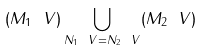Convert formula to latex. <formula><loc_0><loc_0><loc_500><loc_500>( M _ { 1 } \ V ) \bigcup _ { N _ { 1 } \ V = N _ { 2 } \ V } ( M _ { 2 } \ V )</formula> 